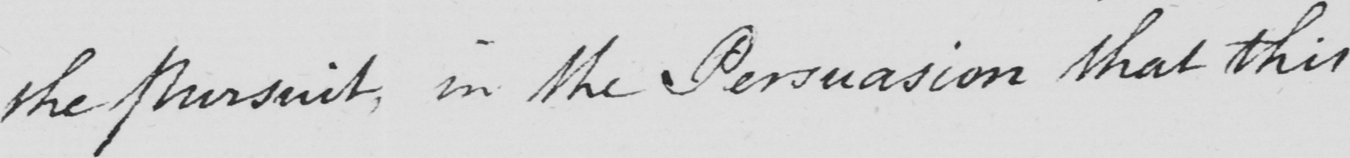Please provide the text content of this handwritten line. the pursuit, in the Persuasion that this 